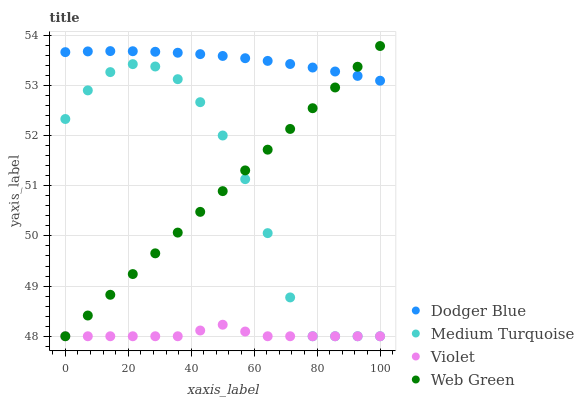Does Violet have the minimum area under the curve?
Answer yes or no. Yes. Does Dodger Blue have the maximum area under the curve?
Answer yes or no. Yes. Does Web Green have the minimum area under the curve?
Answer yes or no. No. Does Web Green have the maximum area under the curve?
Answer yes or no. No. Is Web Green the smoothest?
Answer yes or no. Yes. Is Medium Turquoise the roughest?
Answer yes or no. Yes. Is Medium Turquoise the smoothest?
Answer yes or no. No. Is Web Green the roughest?
Answer yes or no. No. Does Web Green have the lowest value?
Answer yes or no. Yes. Does Web Green have the highest value?
Answer yes or no. Yes. Does Medium Turquoise have the highest value?
Answer yes or no. No. Is Violet less than Dodger Blue?
Answer yes or no. Yes. Is Dodger Blue greater than Medium Turquoise?
Answer yes or no. Yes. Does Web Green intersect Violet?
Answer yes or no. Yes. Is Web Green less than Violet?
Answer yes or no. No. Is Web Green greater than Violet?
Answer yes or no. No. Does Violet intersect Dodger Blue?
Answer yes or no. No. 